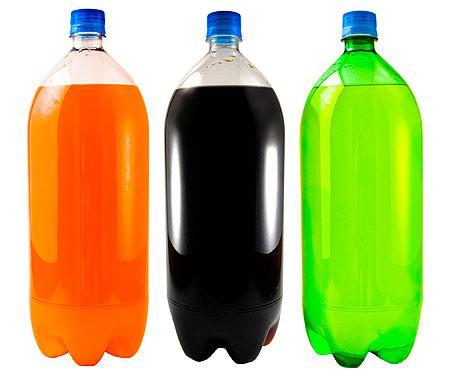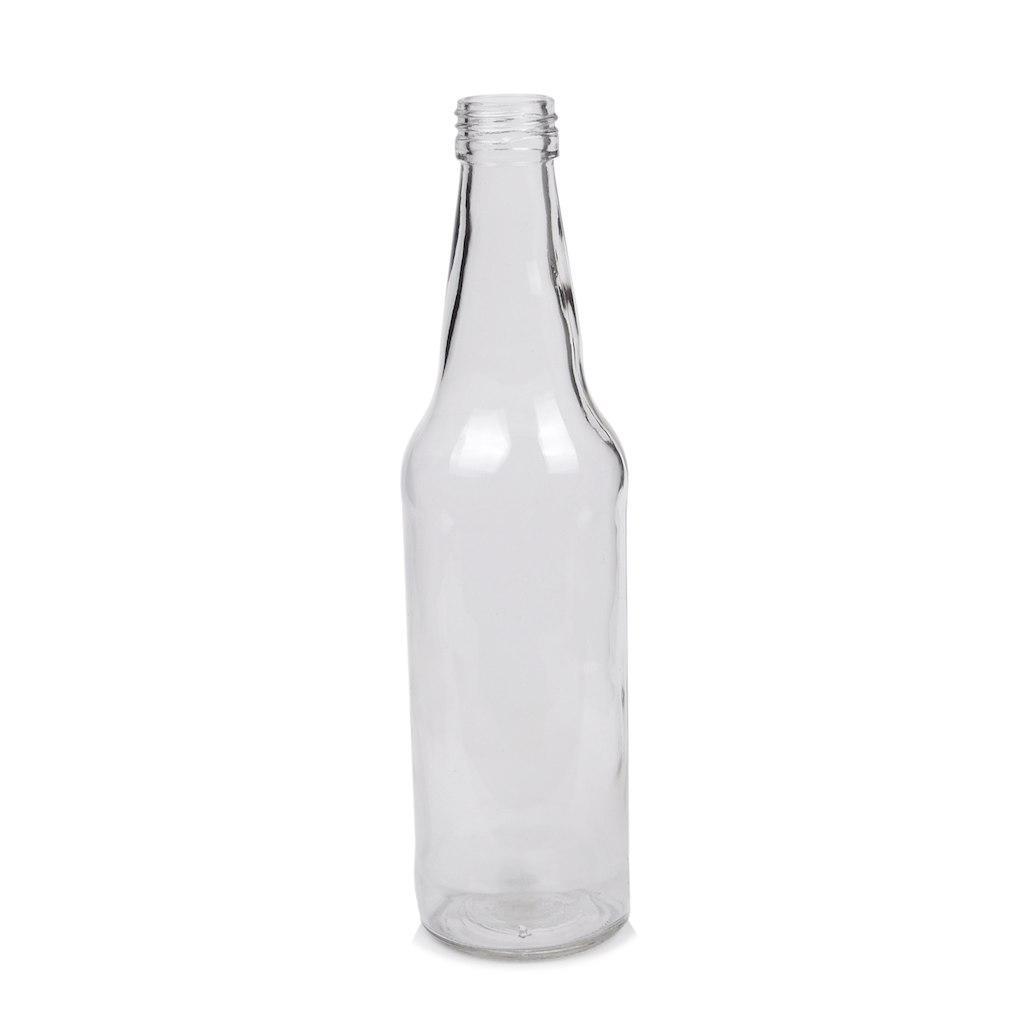The first image is the image on the left, the second image is the image on the right. Considering the images on both sides, is "There is one bottle in one of the images, and three in the other." valid? Answer yes or no. Yes. The first image is the image on the left, the second image is the image on the right. Assess this claim about the two images: "One of the images shows at least one bottle of Coca-Cola.". Correct or not? Answer yes or no. No. 